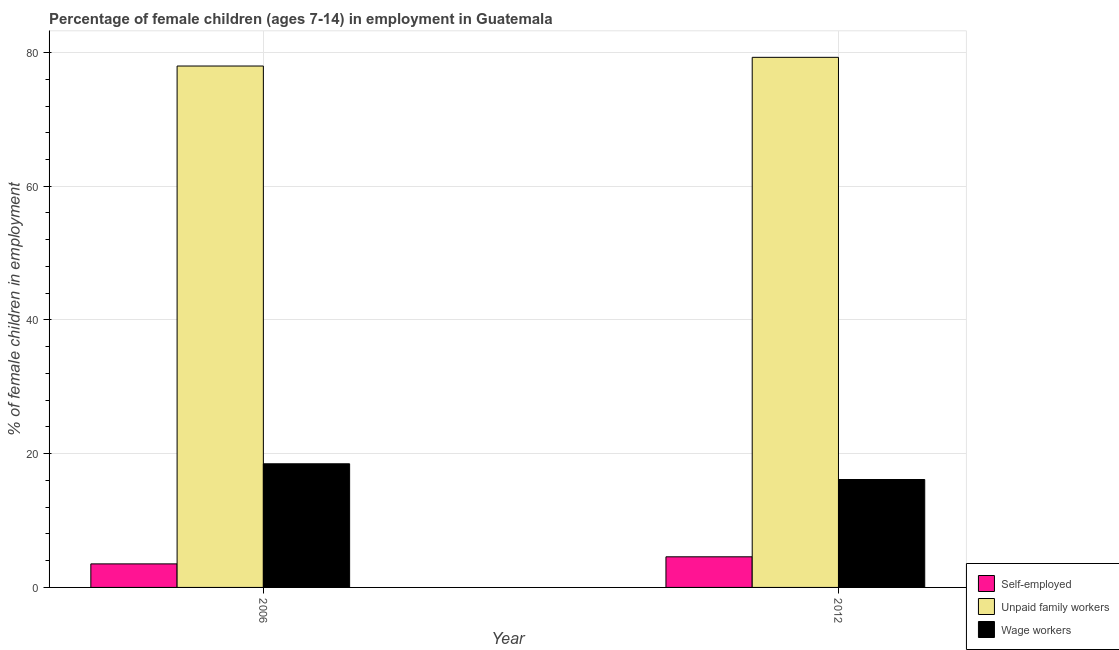How many bars are there on the 1st tick from the right?
Give a very brief answer. 3. What is the percentage of children employed as unpaid family workers in 2012?
Offer a terse response. 79.28. Across all years, what is the maximum percentage of children employed as unpaid family workers?
Ensure brevity in your answer.  79.28. Across all years, what is the minimum percentage of self employed children?
Give a very brief answer. 3.52. What is the total percentage of children employed as unpaid family workers in the graph?
Provide a succinct answer. 157.26. What is the difference between the percentage of self employed children in 2006 and that in 2012?
Your answer should be compact. -1.06. What is the difference between the percentage of children employed as unpaid family workers in 2006 and the percentage of self employed children in 2012?
Give a very brief answer. -1.3. What is the average percentage of children employed as unpaid family workers per year?
Keep it short and to the point. 78.63. In how many years, is the percentage of self employed children greater than 28 %?
Your answer should be very brief. 0. What is the ratio of the percentage of children employed as unpaid family workers in 2006 to that in 2012?
Your answer should be compact. 0.98. Is the percentage of self employed children in 2006 less than that in 2012?
Your answer should be very brief. Yes. In how many years, is the percentage of children employed as wage workers greater than the average percentage of children employed as wage workers taken over all years?
Your answer should be compact. 1. What does the 2nd bar from the left in 2006 represents?
Provide a succinct answer. Unpaid family workers. What does the 3rd bar from the right in 2006 represents?
Offer a terse response. Self-employed. What is the difference between two consecutive major ticks on the Y-axis?
Keep it short and to the point. 20. Does the graph contain any zero values?
Provide a succinct answer. No. Where does the legend appear in the graph?
Make the answer very short. Bottom right. How many legend labels are there?
Provide a succinct answer. 3. How are the legend labels stacked?
Your answer should be very brief. Vertical. What is the title of the graph?
Your answer should be compact. Percentage of female children (ages 7-14) in employment in Guatemala. What is the label or title of the Y-axis?
Make the answer very short. % of female children in employment. What is the % of female children in employment in Self-employed in 2006?
Offer a terse response. 3.52. What is the % of female children in employment of Unpaid family workers in 2006?
Ensure brevity in your answer.  77.98. What is the % of female children in employment in Wage workers in 2006?
Provide a succinct answer. 18.49. What is the % of female children in employment of Self-employed in 2012?
Make the answer very short. 4.58. What is the % of female children in employment of Unpaid family workers in 2012?
Make the answer very short. 79.28. What is the % of female children in employment in Wage workers in 2012?
Offer a very short reply. 16.14. Across all years, what is the maximum % of female children in employment of Self-employed?
Your answer should be very brief. 4.58. Across all years, what is the maximum % of female children in employment of Unpaid family workers?
Ensure brevity in your answer.  79.28. Across all years, what is the maximum % of female children in employment in Wage workers?
Your answer should be very brief. 18.49. Across all years, what is the minimum % of female children in employment in Self-employed?
Make the answer very short. 3.52. Across all years, what is the minimum % of female children in employment of Unpaid family workers?
Your answer should be very brief. 77.98. Across all years, what is the minimum % of female children in employment of Wage workers?
Keep it short and to the point. 16.14. What is the total % of female children in employment of Unpaid family workers in the graph?
Give a very brief answer. 157.26. What is the total % of female children in employment of Wage workers in the graph?
Give a very brief answer. 34.63. What is the difference between the % of female children in employment in Self-employed in 2006 and that in 2012?
Provide a short and direct response. -1.06. What is the difference between the % of female children in employment in Wage workers in 2006 and that in 2012?
Offer a very short reply. 2.35. What is the difference between the % of female children in employment of Self-employed in 2006 and the % of female children in employment of Unpaid family workers in 2012?
Give a very brief answer. -75.76. What is the difference between the % of female children in employment in Self-employed in 2006 and the % of female children in employment in Wage workers in 2012?
Your answer should be compact. -12.62. What is the difference between the % of female children in employment of Unpaid family workers in 2006 and the % of female children in employment of Wage workers in 2012?
Keep it short and to the point. 61.84. What is the average % of female children in employment of Self-employed per year?
Your answer should be compact. 4.05. What is the average % of female children in employment in Unpaid family workers per year?
Give a very brief answer. 78.63. What is the average % of female children in employment of Wage workers per year?
Keep it short and to the point. 17.32. In the year 2006, what is the difference between the % of female children in employment of Self-employed and % of female children in employment of Unpaid family workers?
Offer a very short reply. -74.46. In the year 2006, what is the difference between the % of female children in employment in Self-employed and % of female children in employment in Wage workers?
Give a very brief answer. -14.97. In the year 2006, what is the difference between the % of female children in employment in Unpaid family workers and % of female children in employment in Wage workers?
Offer a very short reply. 59.49. In the year 2012, what is the difference between the % of female children in employment of Self-employed and % of female children in employment of Unpaid family workers?
Your answer should be very brief. -74.7. In the year 2012, what is the difference between the % of female children in employment in Self-employed and % of female children in employment in Wage workers?
Provide a short and direct response. -11.56. In the year 2012, what is the difference between the % of female children in employment in Unpaid family workers and % of female children in employment in Wage workers?
Make the answer very short. 63.14. What is the ratio of the % of female children in employment in Self-employed in 2006 to that in 2012?
Your response must be concise. 0.77. What is the ratio of the % of female children in employment of Unpaid family workers in 2006 to that in 2012?
Make the answer very short. 0.98. What is the ratio of the % of female children in employment of Wage workers in 2006 to that in 2012?
Your response must be concise. 1.15. What is the difference between the highest and the second highest % of female children in employment in Self-employed?
Offer a very short reply. 1.06. What is the difference between the highest and the second highest % of female children in employment of Wage workers?
Ensure brevity in your answer.  2.35. What is the difference between the highest and the lowest % of female children in employment in Self-employed?
Offer a very short reply. 1.06. What is the difference between the highest and the lowest % of female children in employment of Unpaid family workers?
Make the answer very short. 1.3. What is the difference between the highest and the lowest % of female children in employment of Wage workers?
Your response must be concise. 2.35. 